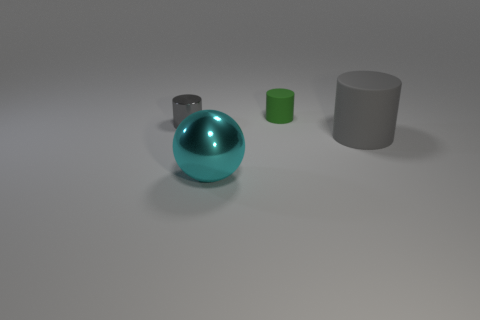What is the size of the rubber thing that is the same color as the metallic cylinder?
Keep it short and to the point. Large. How many tiny objects are gray objects or cyan shiny objects?
Provide a succinct answer. 1. There is a matte cylinder that is the same size as the metallic sphere; what is its color?
Offer a terse response. Gray. What number of other objects are the same shape as the big cyan object?
Provide a short and direct response. 0. Is there a tiny blue cube made of the same material as the big cylinder?
Provide a short and direct response. No. Are the tiny green cylinder that is behind the cyan object and the cylinder left of the large sphere made of the same material?
Your answer should be very brief. No. How many spheres are there?
Your answer should be very brief. 1. There is a big cyan metal thing in front of the green matte cylinder; what shape is it?
Your answer should be very brief. Sphere. What number of other things are there of the same size as the gray metallic cylinder?
Your response must be concise. 1. Does the small gray metal thing behind the metallic sphere have the same shape as the gray object that is in front of the gray metallic cylinder?
Give a very brief answer. Yes. 